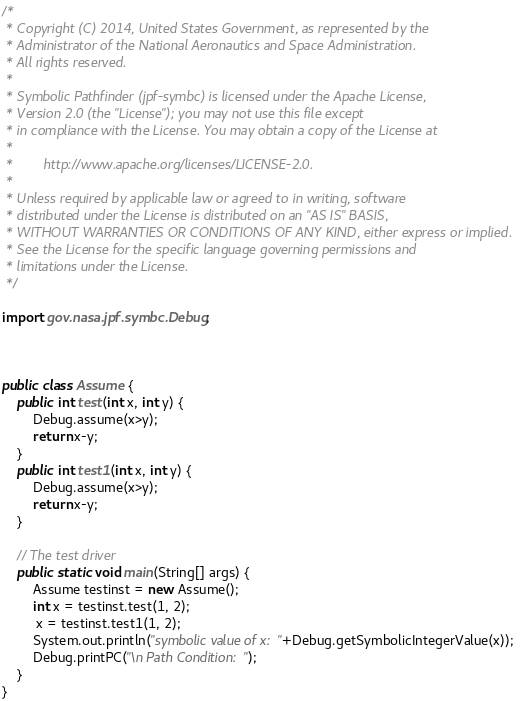<code> <loc_0><loc_0><loc_500><loc_500><_Java_>/*
 * Copyright (C) 2014, United States Government, as represented by the
 * Administrator of the National Aeronautics and Space Administration.
 * All rights reserved.
 *
 * Symbolic Pathfinder (jpf-symbc) is licensed under the Apache License, 
 * Version 2.0 (the "License"); you may not use this file except
 * in compliance with the License. You may obtain a copy of the License at
 * 
 *        http://www.apache.org/licenses/LICENSE-2.0. 
 *
 * Unless required by applicable law or agreed to in writing, software
 * distributed under the License is distributed on an "AS IS" BASIS,
 * WITHOUT WARRANTIES OR CONDITIONS OF ANY KIND, either express or implied.
 * See the License for the specific language governing permissions and 
 * limitations under the License.
 */

import gov.nasa.jpf.symbc.Debug;



public class Assume {
	public int test(int x, int y) {
		Debug.assume(x>y);
		return x-y;
	}
	public int test1(int x, int y) {
		Debug.assume(x>y);
		return x-y;
	}
	
	// The test driver
	public static void main(String[] args) {
		Assume testinst = new Assume();
		int x = testinst.test(1, 2);
		 x = testinst.test1(1, 2);
		System.out.println("symbolic value of x: "+Debug.getSymbolicIntegerValue(x));
		Debug.printPC("\n Path Condition: ");
	}
}</code> 